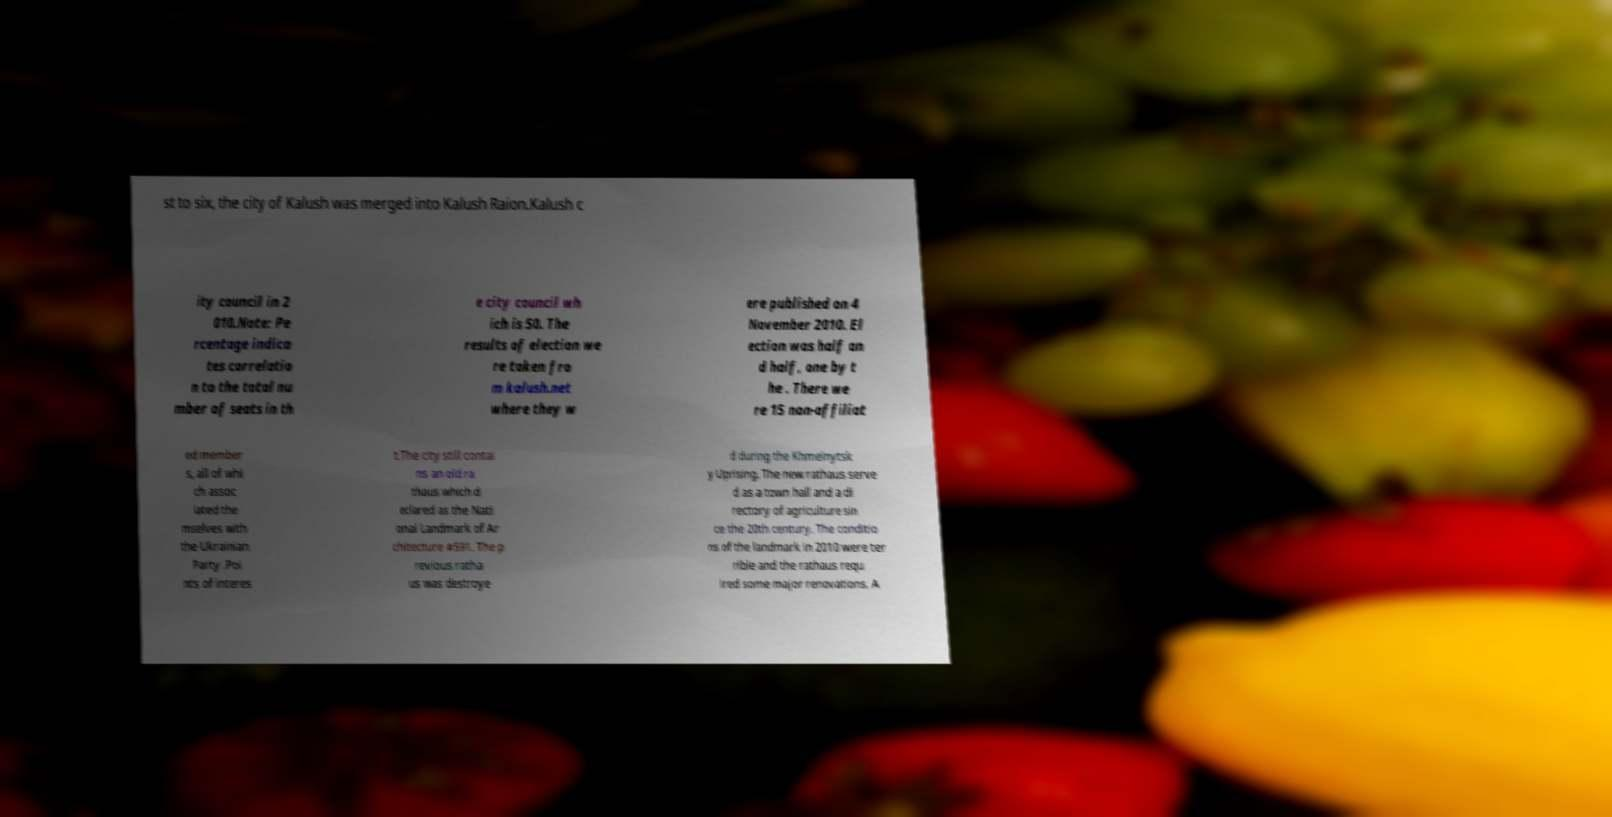Please read and relay the text visible in this image. What does it say? st to six, the city of Kalush was merged into Kalush Raion.Kalush c ity council in 2 010.Note: Pe rcentage indica tes correlatio n to the total nu mber of seats in th e city council wh ich is 50. The results of election we re taken fro m kalush.net where they w ere published on 4 November 2010. El ection was half an d half, one by t he . There we re 15 non-affiliat ed member s, all of whi ch assoc iated the mselves with the Ukrainian Party .Poi nts of interes t.The city still contai ns an old ra thaus which d eclared as the Nati onal Landmark of Ar chitecture #591. The p revious ratha us was destroye d during the Khmelnytsk y Uprising. The new rathaus serve d as a town hall and a di rectory of agriculture sin ce the 20th century. The conditio ns of the landmark in 2010 were ter rible and the rathaus requ ired some major renovations. A 